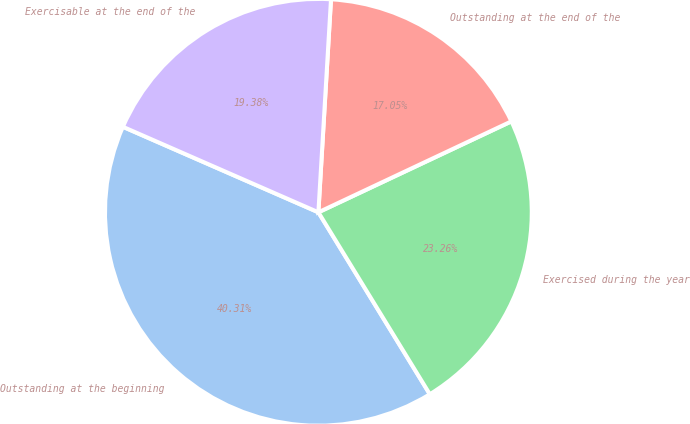Convert chart to OTSL. <chart><loc_0><loc_0><loc_500><loc_500><pie_chart><fcel>Outstanding at the beginning<fcel>Exercised during the year<fcel>Outstanding at the end of the<fcel>Exercisable at the end of the<nl><fcel>40.31%<fcel>23.26%<fcel>17.05%<fcel>19.38%<nl></chart> 